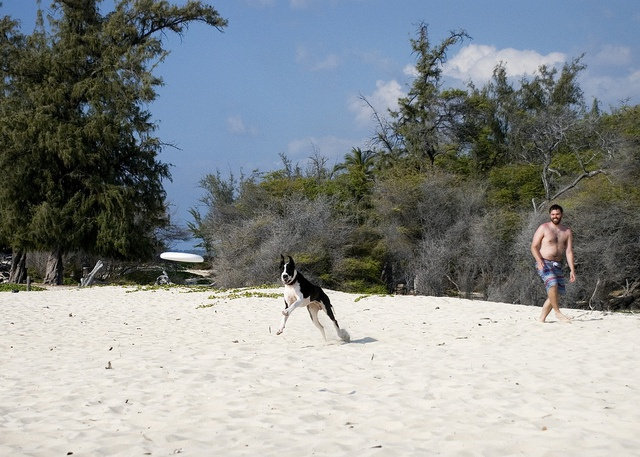Describe the objects in this image and their specific colors. I can see people in gray, tan, and lightgray tones, dog in gray, black, darkgray, and lightgray tones, and frisbee in gray, lightgray, and darkgray tones in this image. 